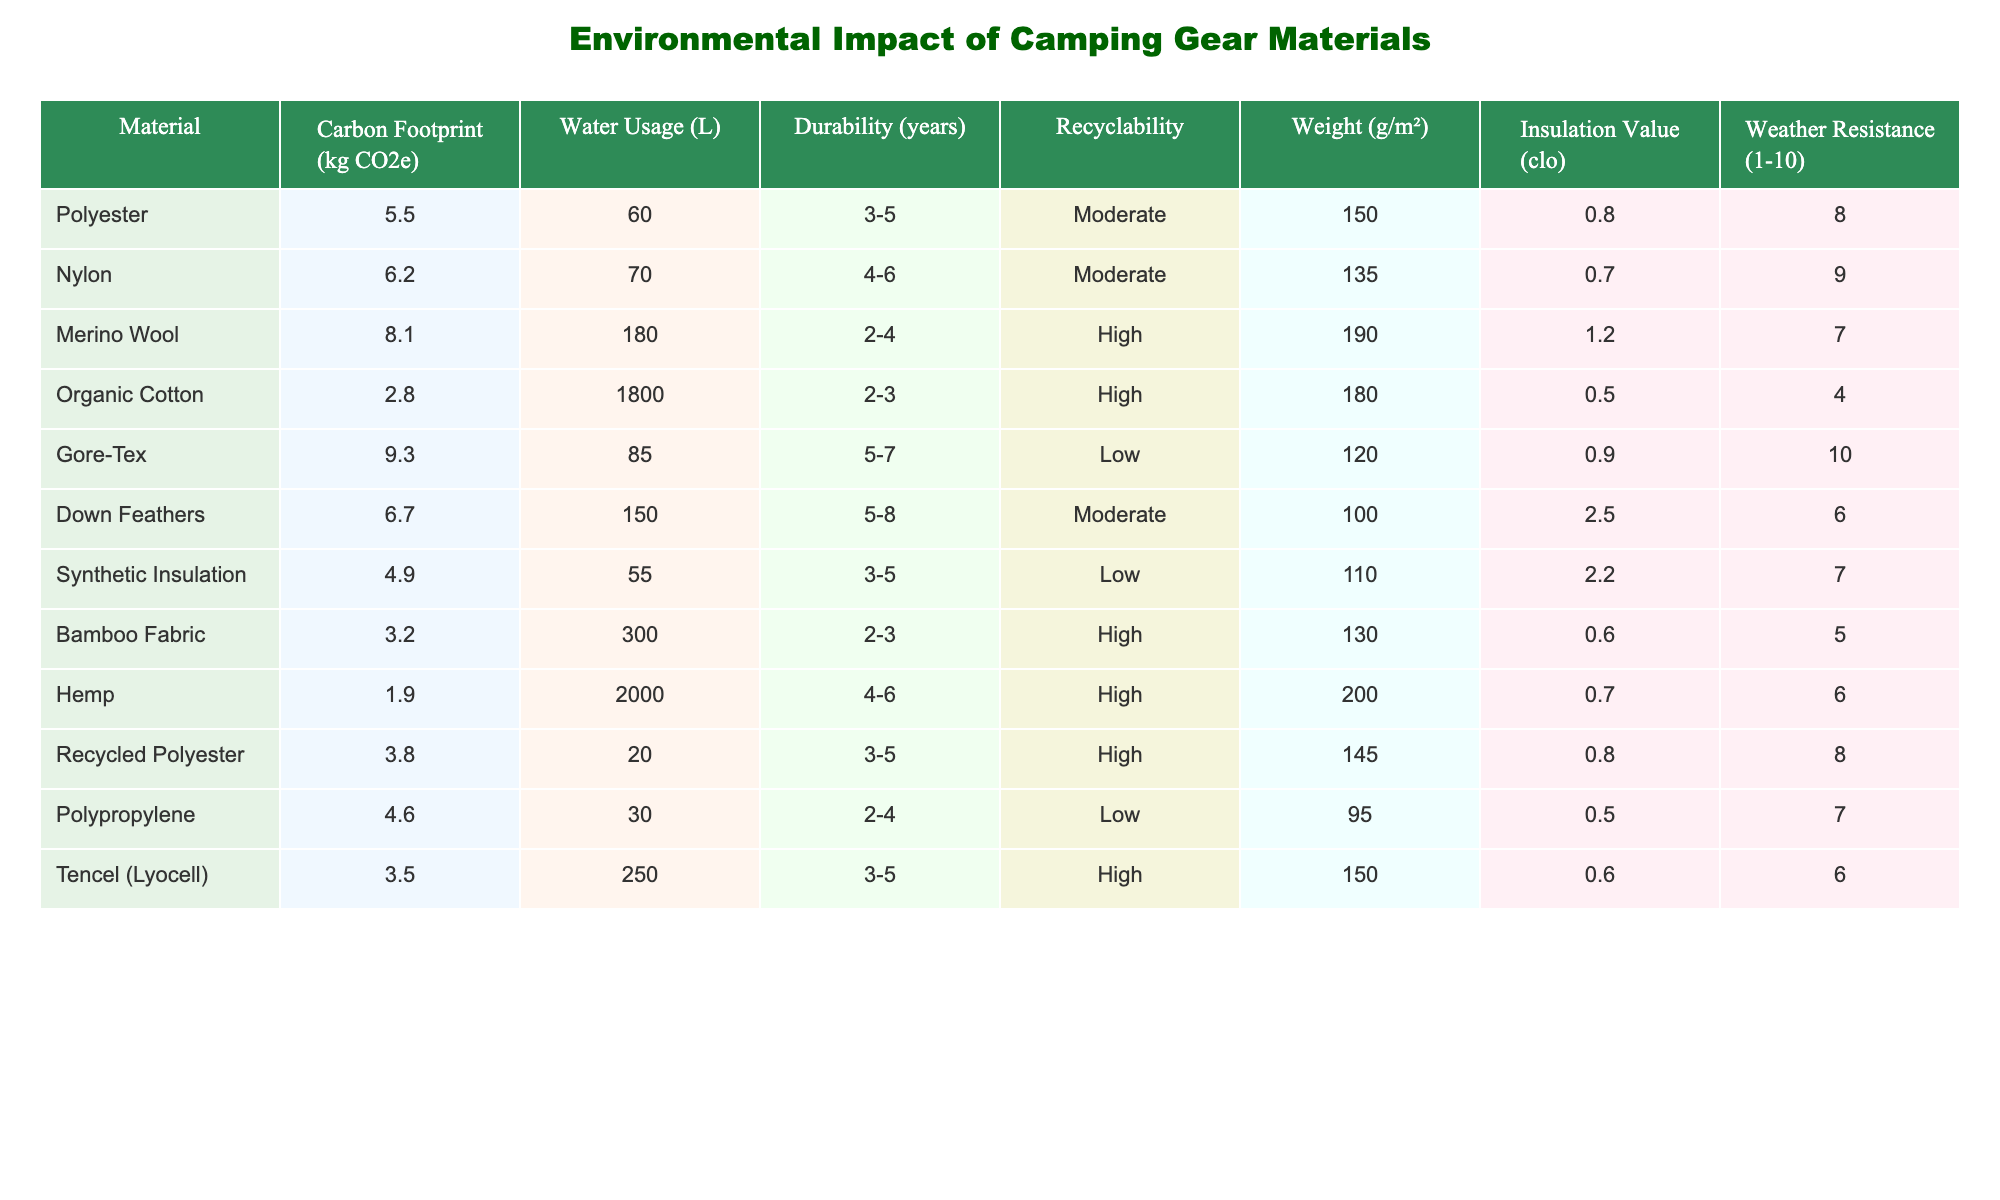What is the material with the highest carbon footprint? The carbon footprint values are listed in the table. By examining the "Carbon Footprint (kg CO2e)" column, we see that Gore-Tex has the highest value at 9.3 kg CO2e.
Answer: Gore-Tex What is the most water-intensive material? The table provides water usage values in the "Water Usage (L)" column. Organic Cotton has the highest water usage at 1800 liters.
Answer: Organic Cotton Does Hemp have a lower carbon footprint than Synthetic Insulation? Looking at the "Carbon Footprint (kg CO2e)" column, Hemp has a value of 1.9 kg CO2e, while Synthetic Insulation has a value of 4.9 kg CO2e. Since 1.9 is less than 4.9, the statement is true.
Answer: Yes What material has the highest insulation value and what is it? The insulation values are found in the "Insulation Value (clo)" column. By reviewing this column, we find that Down Feathers have the highest insulation value at 2.5 clo.
Answer: Down Feathers What is the average durability of all materials listed in the table? To find the average durability, we need to convert the ranges in "Durability (years)" into numerical values. The average can be calculated by first determining the midpoint of each range and then averaging them: (4 + 5 + 3 + 2.5 + 6 + 7 + 5 + 3 + 5.5 + 3 + 2.5 + 2 + 4.5 + 4 + 5) / 14 = 4.24 years (approximately).
Answer: 4.24 years Which material has the best weather resistance? The "Weather Resistance (1-10)" column shows that Gore-Tex has the highest rating at 10.
Answer: Gore-Tex Is Merino Wool more durable than Bamboo Fabric? From the "Durability (years)" column, Merino Wool has a durability range of 2-4 years, and Bamboo Fabric has a range of 2-3 years. Since 4 is greater than 3, Merino Wool is indeed more durable.
Answer: Yes What is the recyclability status of Recycled Polyester? The "Recyclability" column indicates that Recycled Polyester has a status of "High".
Answer: High Which material combination leads to the lowest total weight when used together? By examining the "Weight (g/m²)" column, we find the two lightest materials are Polypropylene (95 g/m²) and Down Feathers (100 g/m²). Adding these gives us a total weight of 195 g/m², which is the lowest combination compared to others.
Answer: 195 g/m² 